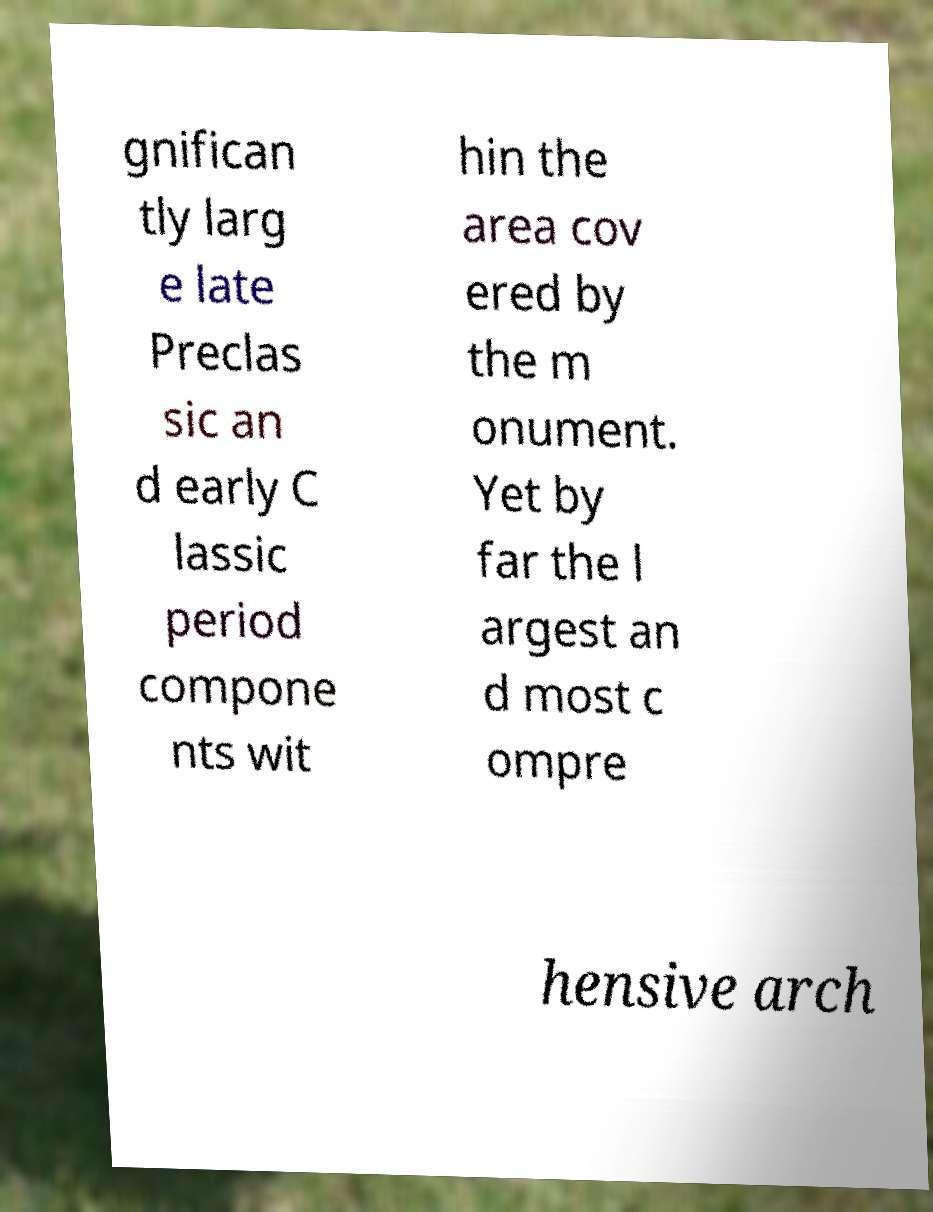Can you accurately transcribe the text from the provided image for me? gnifican tly larg e late Preclas sic an d early C lassic period compone nts wit hin the area cov ered by the m onument. Yet by far the l argest an d most c ompre hensive arch 